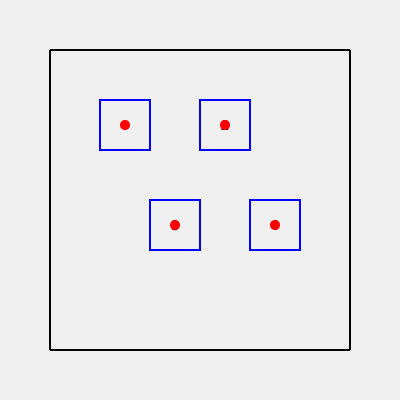Based on the footprint pattern shown on the stage floor, what is the correct sequence of dance moves for the "Blue Suede Shoes Shuffle"? To determine the correct sequence of dance moves:

1. Observe the numbered squares representing dance positions.
2. Notice the red dots indicating foot placement within each square.
3. Analyze the layout:
   - Positions 1 and 2 are on the top row
   - Positions 3 and 4 are on the bottom row
4. Consider the natural flow of movement:
   - Start with the leftmost position (1)
   - Move right to position 2
   - Shift diagonally down-left to position 3
   - End with a diagonal move up-right to position 4
5. This creates a smooth, Z-shaped pattern typical of many Elvis dance routines.

The sequence follows a logical progression from left to right and top to bottom, mimicking the iconic Elvis footwork style.
Answer: 1-2-3-4 